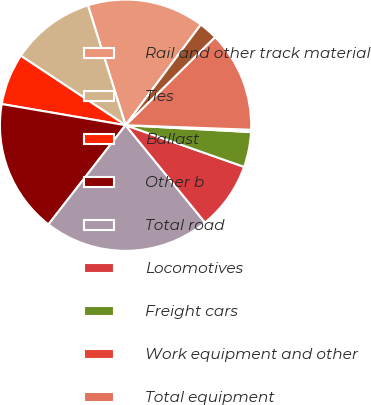Convert chart. <chart><loc_0><loc_0><loc_500><loc_500><pie_chart><fcel>Rail and other track material<fcel>Ties<fcel>Ballast<fcel>Other b<fcel>Total road<fcel>Locomotives<fcel>Freight cars<fcel>Work equipment and other<fcel>Total equipment<fcel>Technology and other<nl><fcel>15.06%<fcel>10.84%<fcel>6.62%<fcel>17.18%<fcel>21.4%<fcel>8.73%<fcel>4.51%<fcel>0.29%<fcel>12.95%<fcel>2.4%<nl></chart> 